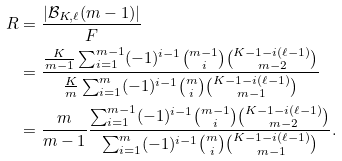<formula> <loc_0><loc_0><loc_500><loc_500>R & = \frac { | \mathcal { B } _ { K , \ell } ( m - 1 ) | } { F } \\ & = \frac { \frac { K } { m - 1 } \sum _ { i = 1 } ^ { m - 1 } ( - 1 ) ^ { i - 1 } \binom { m - 1 } { i } \binom { K - 1 - i ( \ell - 1 ) } { m - 2 } } { \frac { K } { m } \sum _ { i = 1 } ^ { m } ( - 1 ) ^ { i - 1 } \binom { m } { i } \binom { K - 1 - i ( \ell - 1 ) } { m - 1 } } \\ & = \frac { m } { m - 1 } \frac { \sum _ { i = 1 } ^ { m - 1 } ( - 1 ) ^ { i - 1 } \binom { m - 1 } { i } \binom { K - 1 - i ( \ell - 1 ) } { m - 2 } } { \sum _ { i = 1 } ^ { m } ( - 1 ) ^ { i - 1 } \binom { m } { i } \binom { K - 1 - i ( \ell - 1 ) } { m - 1 } } .</formula> 